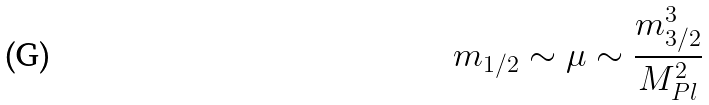<formula> <loc_0><loc_0><loc_500><loc_500>m _ { 1 / 2 } \sim \mu \sim \frac { m _ { 3 / 2 } ^ { 3 } } { M _ { P l } ^ { 2 } }</formula> 